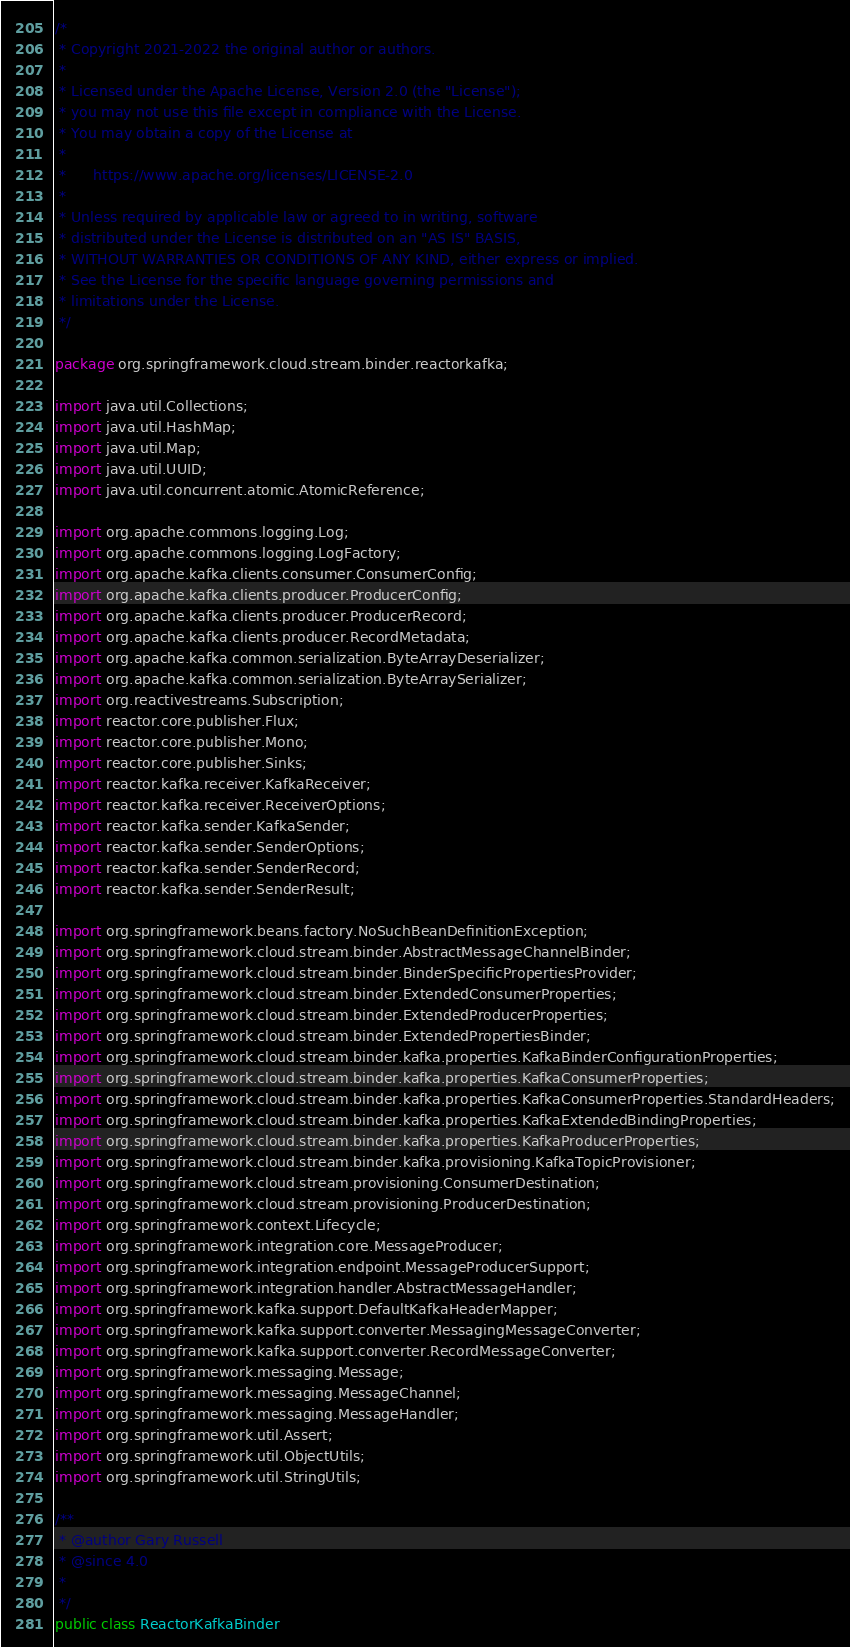Convert code to text. <code><loc_0><loc_0><loc_500><loc_500><_Java_>/*
 * Copyright 2021-2022 the original author or authors.
 *
 * Licensed under the Apache License, Version 2.0 (the "License");
 * you may not use this file except in compliance with the License.
 * You may obtain a copy of the License at
 *
 *      https://www.apache.org/licenses/LICENSE-2.0
 *
 * Unless required by applicable law or agreed to in writing, software
 * distributed under the License is distributed on an "AS IS" BASIS,
 * WITHOUT WARRANTIES OR CONDITIONS OF ANY KIND, either express or implied.
 * See the License for the specific language governing permissions and
 * limitations under the License.
 */

package org.springframework.cloud.stream.binder.reactorkafka;

import java.util.Collections;
import java.util.HashMap;
import java.util.Map;
import java.util.UUID;
import java.util.concurrent.atomic.AtomicReference;

import org.apache.commons.logging.Log;
import org.apache.commons.logging.LogFactory;
import org.apache.kafka.clients.consumer.ConsumerConfig;
import org.apache.kafka.clients.producer.ProducerConfig;
import org.apache.kafka.clients.producer.ProducerRecord;
import org.apache.kafka.clients.producer.RecordMetadata;
import org.apache.kafka.common.serialization.ByteArrayDeserializer;
import org.apache.kafka.common.serialization.ByteArraySerializer;
import org.reactivestreams.Subscription;
import reactor.core.publisher.Flux;
import reactor.core.publisher.Mono;
import reactor.core.publisher.Sinks;
import reactor.kafka.receiver.KafkaReceiver;
import reactor.kafka.receiver.ReceiverOptions;
import reactor.kafka.sender.KafkaSender;
import reactor.kafka.sender.SenderOptions;
import reactor.kafka.sender.SenderRecord;
import reactor.kafka.sender.SenderResult;

import org.springframework.beans.factory.NoSuchBeanDefinitionException;
import org.springframework.cloud.stream.binder.AbstractMessageChannelBinder;
import org.springframework.cloud.stream.binder.BinderSpecificPropertiesProvider;
import org.springframework.cloud.stream.binder.ExtendedConsumerProperties;
import org.springframework.cloud.stream.binder.ExtendedProducerProperties;
import org.springframework.cloud.stream.binder.ExtendedPropertiesBinder;
import org.springframework.cloud.stream.binder.kafka.properties.KafkaBinderConfigurationProperties;
import org.springframework.cloud.stream.binder.kafka.properties.KafkaConsumerProperties;
import org.springframework.cloud.stream.binder.kafka.properties.KafkaConsumerProperties.StandardHeaders;
import org.springframework.cloud.stream.binder.kafka.properties.KafkaExtendedBindingProperties;
import org.springframework.cloud.stream.binder.kafka.properties.KafkaProducerProperties;
import org.springframework.cloud.stream.binder.kafka.provisioning.KafkaTopicProvisioner;
import org.springframework.cloud.stream.provisioning.ConsumerDestination;
import org.springframework.cloud.stream.provisioning.ProducerDestination;
import org.springframework.context.Lifecycle;
import org.springframework.integration.core.MessageProducer;
import org.springframework.integration.endpoint.MessageProducerSupport;
import org.springframework.integration.handler.AbstractMessageHandler;
import org.springframework.kafka.support.DefaultKafkaHeaderMapper;
import org.springframework.kafka.support.converter.MessagingMessageConverter;
import org.springframework.kafka.support.converter.RecordMessageConverter;
import org.springframework.messaging.Message;
import org.springframework.messaging.MessageChannel;
import org.springframework.messaging.MessageHandler;
import org.springframework.util.Assert;
import org.springframework.util.ObjectUtils;
import org.springframework.util.StringUtils;

/**
 * @author Gary Russell
 * @since 4.0
 *
 */
public class ReactorKafkaBinder</code> 